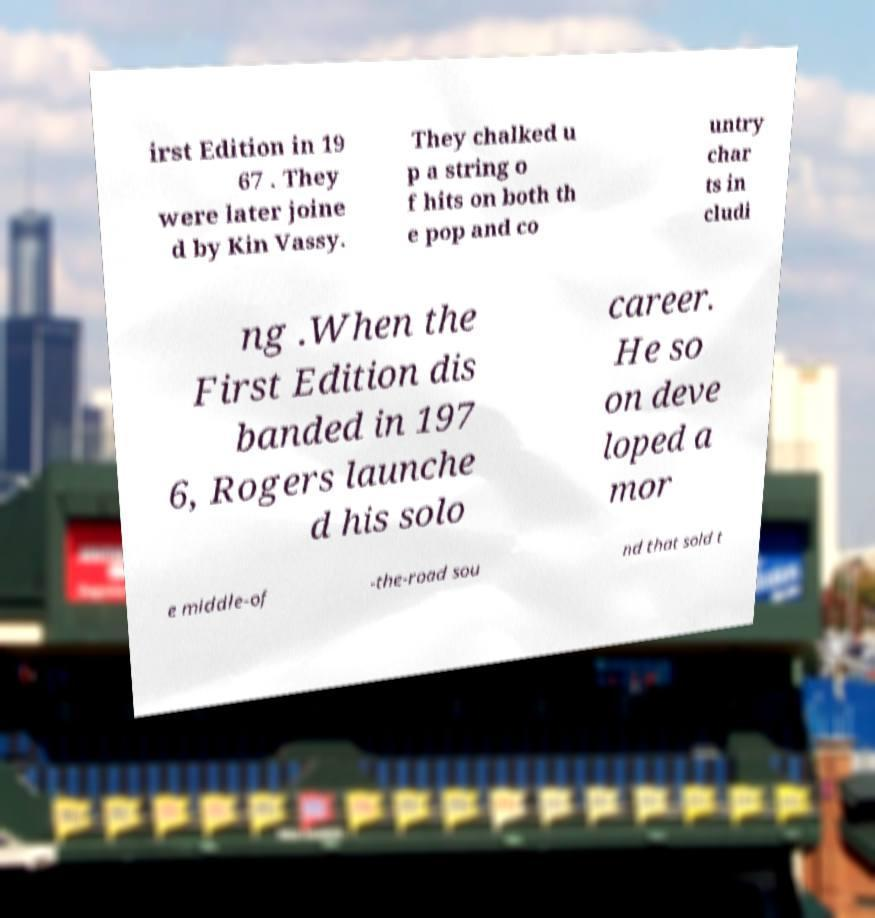Can you accurately transcribe the text from the provided image for me? irst Edition in 19 67 . They were later joine d by Kin Vassy. They chalked u p a string o f hits on both th e pop and co untry char ts in cludi ng .When the First Edition dis banded in 197 6, Rogers launche d his solo career. He so on deve loped a mor e middle-of -the-road sou nd that sold t 